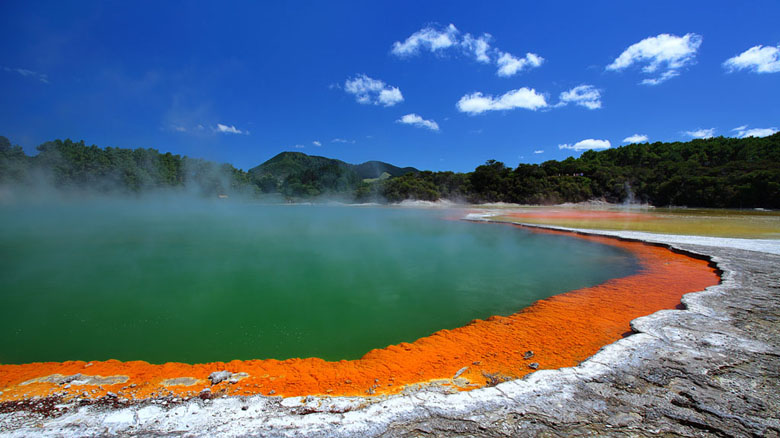Imagine a story where this hot spring was discovered by an ancient civilization. What impact did it have on their culture? In a distant past, an ancient civilization discovered this vibrant hot spring nestled in the heart of what would later be known as Wai-O-Tapu Thermal Wonderland. The discovery of the spring had a profound impact on their culture and beliefs. To them, the bright orange and green waters were not merely a natural spectacle but a sacred site, believed to be a portal to the underworld or a dwelling place of the gods.

Their high priests declared the area sacred ground, and rituals were performed here to honor the Earth’s spirits. The intense geothermal activity was seen as a sign of divine energy, and the civilization built temples near the hot spring, adorned with carvings depicting their deities and the awe-inspiring power of the spring. The minerals found in the area were believed to possess healing properties, and people traveled great distances to bathe in the waters, seeking cures and blessings.

Festivals were held annually, where people gathered to offer gifts to the gods and celebrate the life-giving forces they believed emanated from the spring. This site became a center for not just spirituality but also scientific curiosity. The temperature variations and bubbling waters inspired early theories about the Earth's interior, laying the foundation for the civilization's understanding of geology and natural phenomena.

This ancient civilization's reverence for the hot spring permeated every aspect of their society, from their religious practices to their advancements in science and medicine, forever shaping their history and culture. 